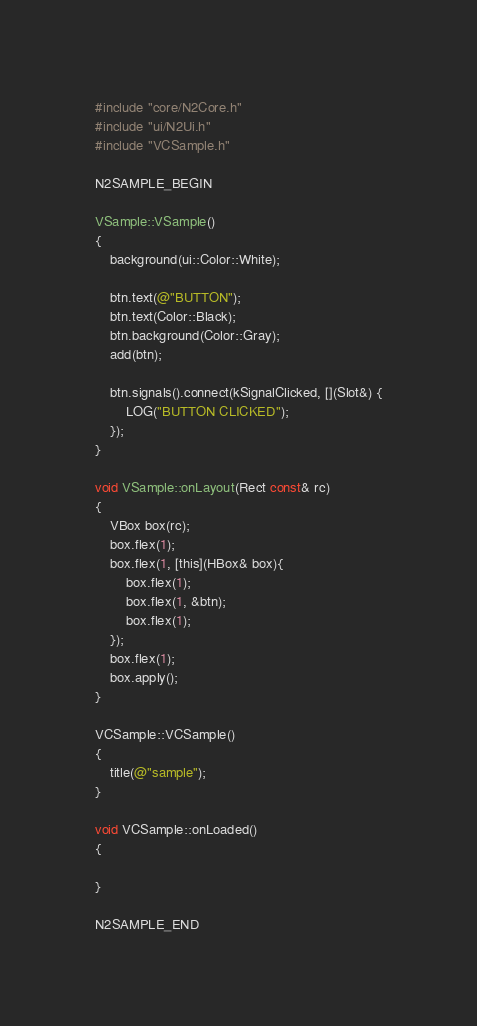<code> <loc_0><loc_0><loc_500><loc_500><_ObjectiveC_>
#include "core/N2Core.h"
#include "ui/N2Ui.h"
#include "VCSample.h"

N2SAMPLE_BEGIN

VSample::VSample()
{
    background(ui::Color::White);
    
    btn.text(@"BUTTON");
    btn.text(Color::Black);
    btn.background(Color::Gray);
    add(btn);
    
    btn.signals().connect(kSignalClicked, [](Slot&) {
        LOG("BUTTON CLICKED");
    });
}

void VSample::onLayout(Rect const& rc)
{
    VBox box(rc);
    box.flex(1);
    box.flex(1, [this](HBox& box){
        box.flex(1);
        box.flex(1, &btn);
        box.flex(1);
    });
    box.flex(1);
    box.apply();
}

VCSample::VCSample()
{
    title(@"sample");
}

void VCSample::onLoaded()
{
    
}

N2SAMPLE_END
</code> 